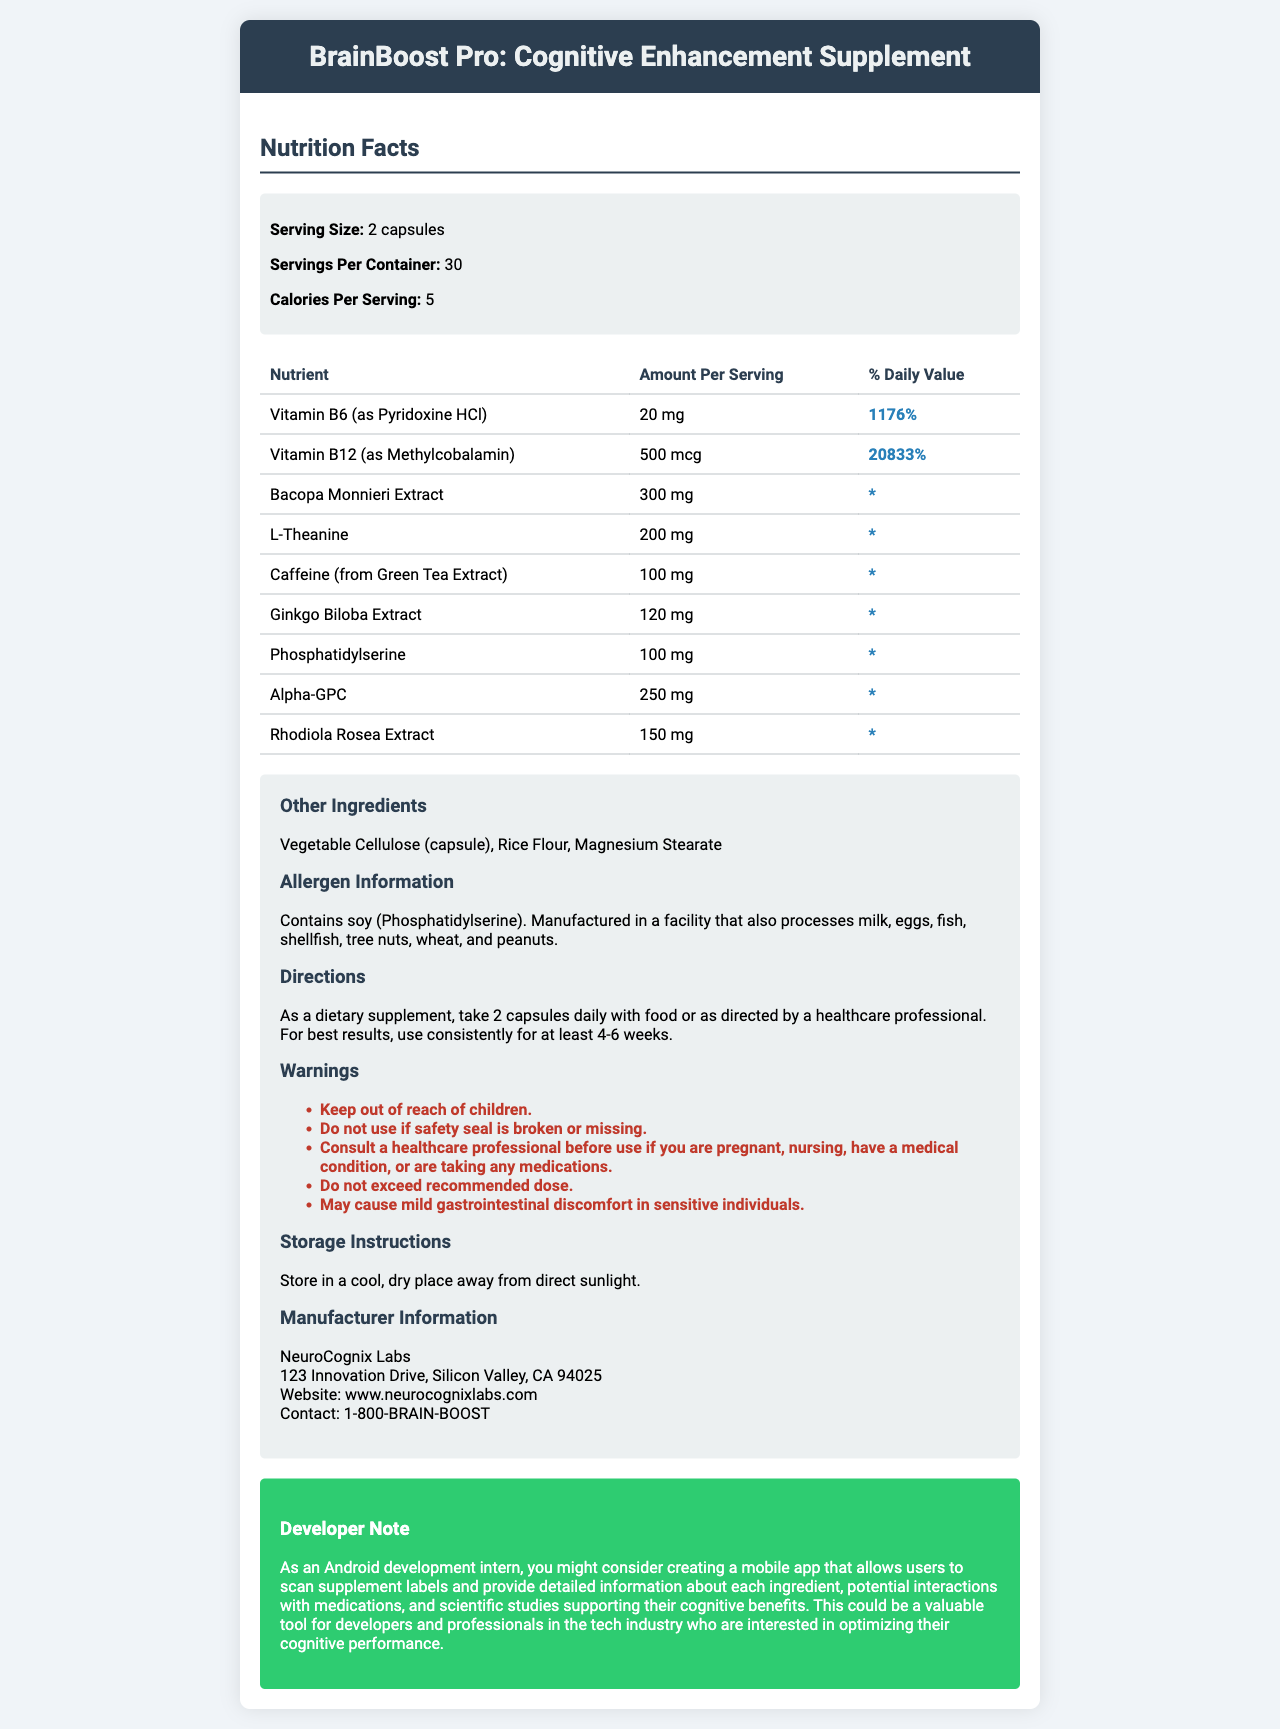what is the serving size of BrainBoost Pro? The serving size is explicitly mentioned as "2 capsules" in the document.
Answer: 2 capsules how many servings are there per container? The document specifies that there are 30 servings per container.
Answer: 30 how many calories are there per serving? The document states that each serving contains 5 calories.
Answer: 5 calories which vitamin has the highest daily value percentage? Vitamin B12 has a daily value percentage of 20833%, which is the highest among the listed vitamins and nutrients.
Answer: Vitamin B12 (as Methylcobalamin) what should you do if the safety seal is broken or missing? One of the warnings in the document advises against using the supplement if the safety seal is broken or missing.
Answer: Do not use how much L-Theanine is in each serving of BrainBoost Pro? A. 100 mg B. 200 mg C. 300 mg D. 400 mg The document lists 200 mg of L-Theanine per serving.
Answer: B. 200 mg how often should you take BrainBoost Pro for best results? A. Every other day B. Once a week C. Daily D. Twice a day The directions state to take 2 capsules daily for best results.
Answer: C. Daily which of the following is NOT listed as an ingredient in BrainBoost Pro? A. Vegetable Cellulose B. Rice Flour C. Magnesium Stearate D. Gelatin Gelatin is not listed among the ingredients in BrainBoost Pro.
Answer: D. Gelatin does BrainBoost Pro contain allergens? The document mentions that it contains soy (Phosphatidylserine) and is manufactured in a facility that processes other common allergens.
Answer: Yes summarize the main idea of the document. The document describes in detail the nutritional information, ingredients, usage directions, and other important details about the BrainBoost Pro supplement.
Answer: BrainBoost Pro is a cognitive enhancement supplement designed to improve cognitive function and focus. It contains a variety of vitamins and herbal extracts. The document provides detailed information on the nutrients per serving, other ingredients, allergen information, directions for use, warnings, and manufacturer details. what are the benefits of Bacopa Monnieri Extract as stated in the document? The document lists Bacopa Monnieri Extract as an ingredient but does not explicitly mention its benefits.
Answer: Not enough information what is the name of the manufacturer of BrainBoost Pro? The manufacturer information section at the end of the document specifies the name "NeuroCognix Labs."
Answer: NeuroCognix Labs how much caffeine is in each serving of BrainBoost Pro? The document mentions there are 100 mg of caffeine (from Green Tea Extract) per serving.
Answer: 100 mg does the document mention storage instructions for BrainBoost Pro? The document states: "Store in a cool, dry place away from direct sunlight."
Answer: Yes what should you do before using BrainBoost Pro if you are pregnant or nursing? One of the warnings advises consulting a healthcare professional if you are pregnant or nursing.
Answer: Consult a healthcare professional 